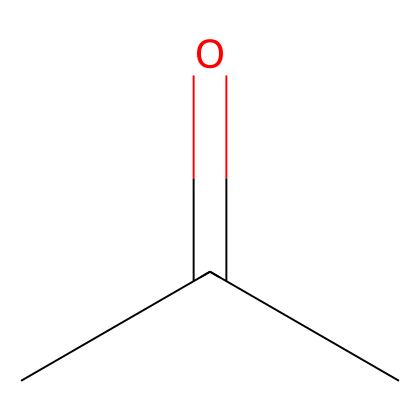What is the molecular formula of this compound? The SMILES representation CC(=O)C indicates that there are three carbon atoms (C), six hydrogen atoms (H), and one oxygen atom (O). Therefore, the molecular formula can be deduced as C3H6O.
Answer: C3H6O How many carbon atoms are present in acetone? By analyzing the SMILES representation CC(=O)C, we can see that there are three 'C' entries, indicating three carbon atoms in total.
Answer: three What type of bond is present between the carbon and oxygen in acetone? The '=' symbol in the SMILES representation CC(=O)C indicates a double bond between the carbon and oxygen atom, which is characteristic of the carbonyl functional group found in ketones.
Answer: double bond What functional group is characteristic of ketones in this structure? The carbonyl group (C=O) is present in the structure, indicated by the 'C(=O)' part of the SMILES. This functional group is essential for classifying the compound as a ketone.
Answer: carbonyl group What is the total number of hydrogen atoms in acetone? The structure implies three carbon atoms, and according to the structure of ketones, each carbon typically connects with enough hydrogens to fulfill its tetravalency. Here, each carbon would have two or three hydrogen atoms attached, leading to a total of six hydrogen atoms.
Answer: six What is the boiling point range of acetone? Acetone has a known boiling point around 56 degrees Celsius, a characteristic property of this solvent. This can be inferred from its molecular characteristics commonly observed in the literature.
Answer: 56 degrees Celsius Is acetone a polar or nonpolar solvent? The presence of the polar carbonyl group (C=O) makes acetone a polar solvent, but its overall hydrocarbon structure gives it some nonpolar characteristics as well. Nevertheless, the dominant feature is its polarity.
Answer: polar 